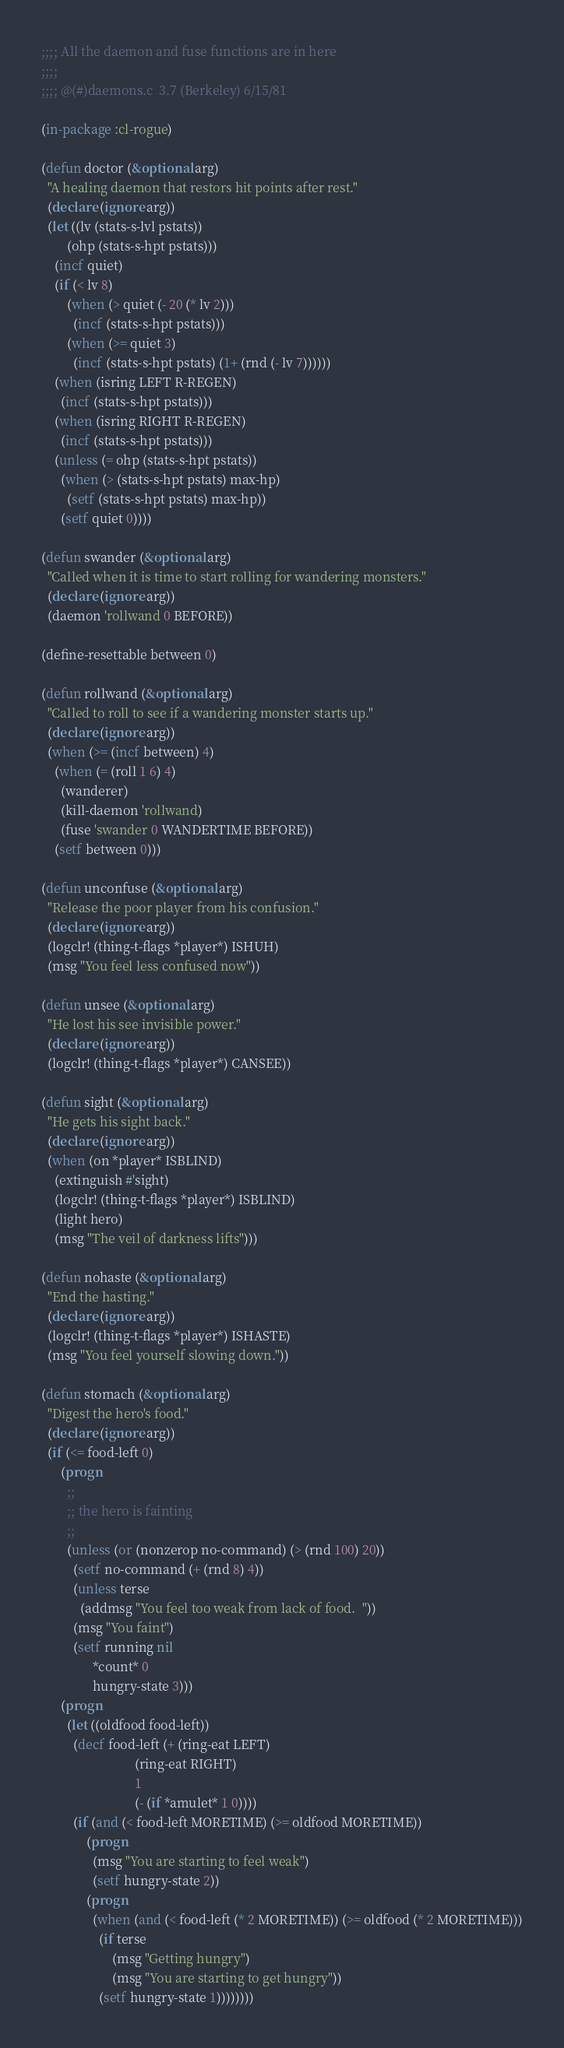<code> <loc_0><loc_0><loc_500><loc_500><_Lisp_>;;;; All the daemon and fuse functions are in here
;;;;
;;;; @(#)daemons.c	3.7 (Berkeley) 6/15/81

(in-package :cl-rogue)

(defun doctor (&optional arg)
  "A healing daemon that restors hit points after rest."
  (declare (ignore arg))
  (let ((lv (stats-s-lvl pstats))
        (ohp (stats-s-hpt pstats)))
    (incf quiet)
    (if (< lv 8)
        (when (> quiet (- 20 (* lv 2)))
          (incf (stats-s-hpt pstats)))
        (when (>= quiet 3)
          (incf (stats-s-hpt pstats) (1+ (rnd (- lv 7))))))
    (when (isring LEFT R-REGEN)
      (incf (stats-s-hpt pstats)))
    (when (isring RIGHT R-REGEN)
      (incf (stats-s-hpt pstats)))
    (unless (= ohp (stats-s-hpt pstats))
      (when (> (stats-s-hpt pstats) max-hp)
        (setf (stats-s-hpt pstats) max-hp))
      (setf quiet 0))))

(defun swander (&optional arg)
  "Called when it is time to start rolling for wandering monsters."
  (declare (ignore arg))
  (daemon 'rollwand 0 BEFORE))

(define-resettable between 0)

(defun rollwand (&optional arg)
  "Called to roll to see if a wandering monster starts up."
  (declare (ignore arg))
  (when (>= (incf between) 4)
    (when (= (roll 1 6) 4)
      (wanderer)
      (kill-daemon 'rollwand)
      (fuse 'swander 0 WANDERTIME BEFORE))
    (setf between 0)))

(defun unconfuse (&optional arg)
  "Release the poor player from his confusion."
  (declare (ignore arg))
  (logclr! (thing-t-flags *player*) ISHUH)
  (msg "You feel less confused now"))

(defun unsee (&optional arg)
  "He lost his see invisible power."
  (declare (ignore arg))
  (logclr! (thing-t-flags *player*) CANSEE))

(defun sight (&optional arg)
  "He gets his sight back."
  (declare (ignore arg))
  (when (on *player* ISBLIND)
    (extinguish #'sight)
    (logclr! (thing-t-flags *player*) ISBLIND)
    (light hero)
    (msg "The veil of darkness lifts")))

(defun nohaste (&optional arg)
  "End the hasting."
  (declare (ignore arg))
  (logclr! (thing-t-flags *player*) ISHASTE)
  (msg "You feel yourself slowing down."))

(defun stomach (&optional arg)
  "Digest the hero's food."
  (declare (ignore arg))
  (if (<= food-left 0)
      (progn
        ;;
        ;; the hero is fainting
        ;;
        (unless (or (nonzerop no-command) (> (rnd 100) 20))
          (setf no-command (+ (rnd 8) 4))
          (unless terse
            (addmsg "You feel too weak from lack of food.  "))
          (msg "You faint")
          (setf running nil
                *count* 0
                hungry-state 3)))
      (progn
        (let ((oldfood food-left))
          (decf food-left (+ (ring-eat LEFT) 
                             (ring-eat RIGHT) 
                             1 
                             (- (if *amulet* 1 0))))
          (if (and (< food-left MORETIME) (>= oldfood MORETIME))
              (progn
                (msg "You are starting to feel weak")
                (setf hungry-state 2))
              (progn
                (when (and (< food-left (* 2 MORETIME)) (>= oldfood (* 2 MORETIME)))
                  (if terse
                      (msg "Getting hungry")
                      (msg "You are starting to get hungry"))
                  (setf hungry-state 1))))))))
</code> 